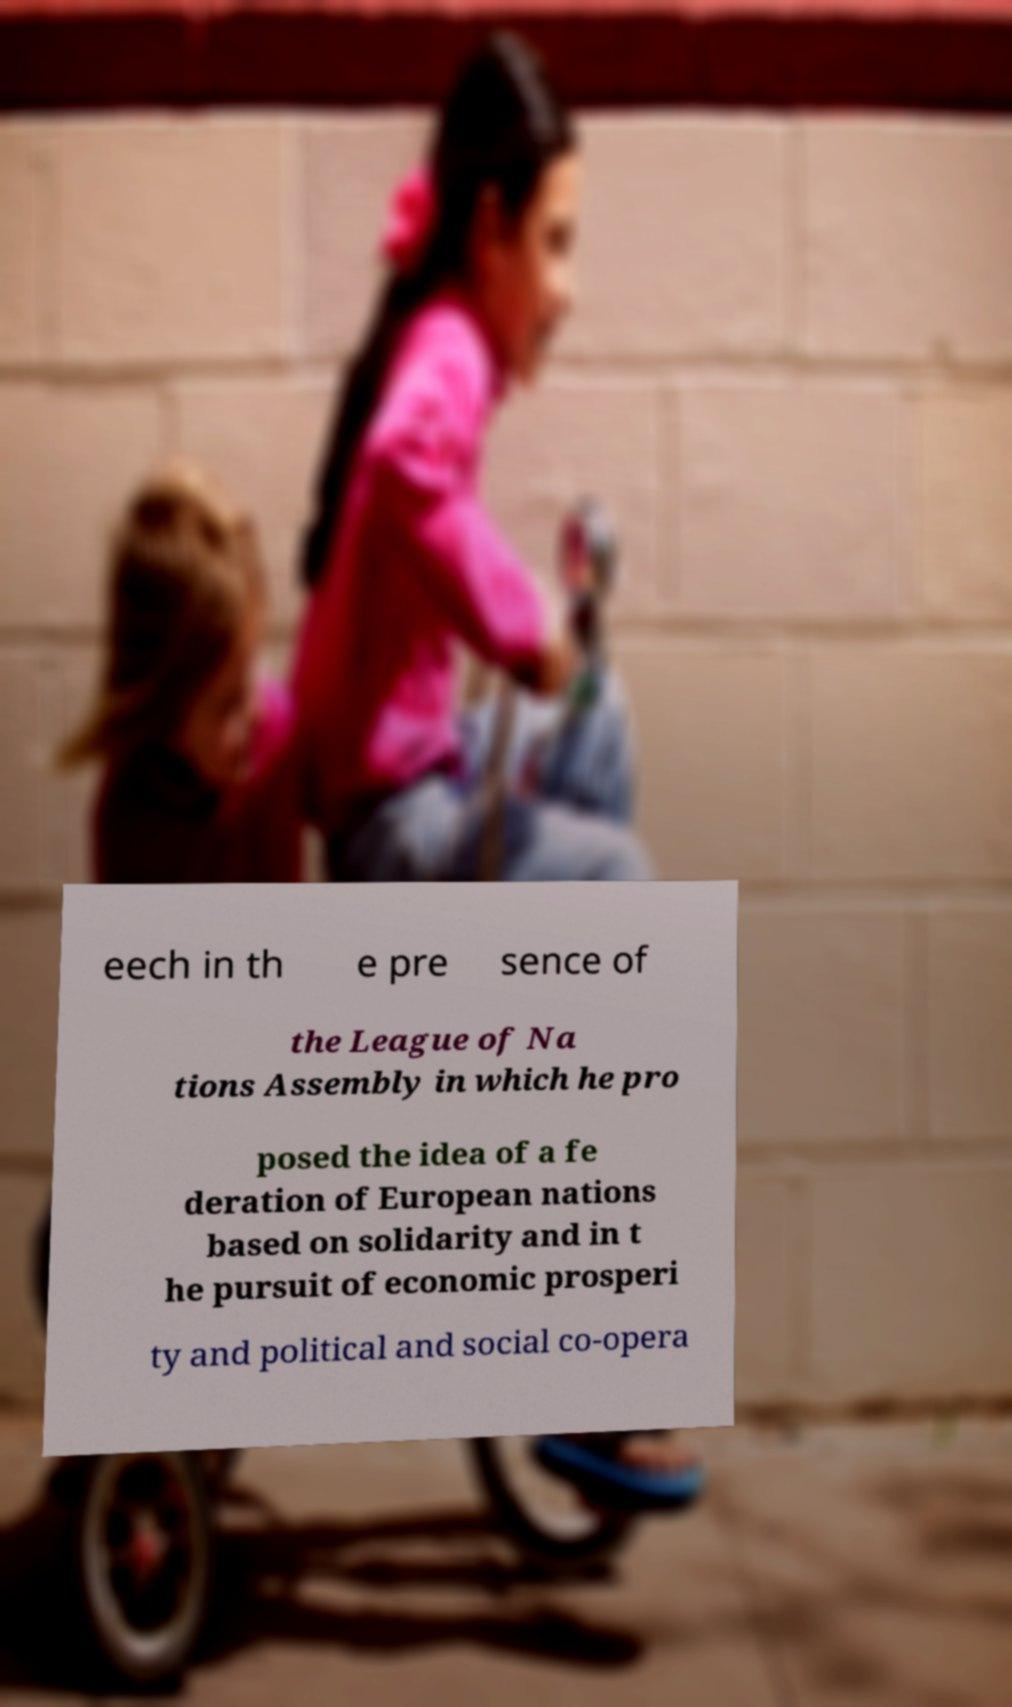Please read and relay the text visible in this image. What does it say? eech in th e pre sence of the League of Na tions Assembly in which he pro posed the idea of a fe deration of European nations based on solidarity and in t he pursuit of economic prosperi ty and political and social co-opera 